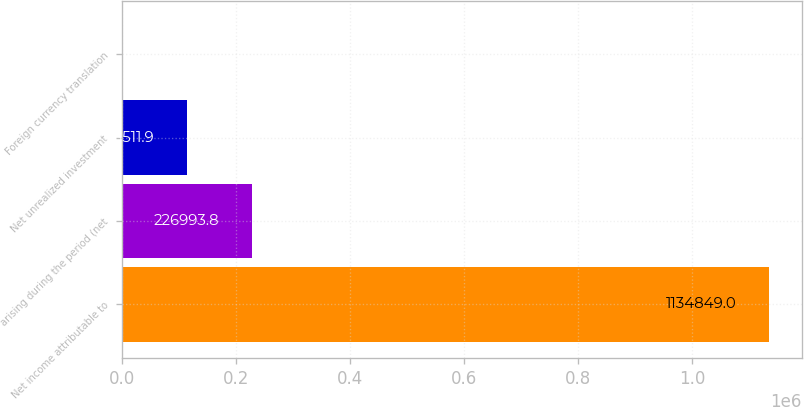Convert chart. <chart><loc_0><loc_0><loc_500><loc_500><bar_chart><fcel>Net income attributable to<fcel>arising during the period (net<fcel>Net unrealized investment<fcel>Foreign currency translation<nl><fcel>1.13485e+06<fcel>226994<fcel>113512<fcel>30<nl></chart> 